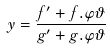Convert formula to latex. <formula><loc_0><loc_0><loc_500><loc_500>y = \frac { f ^ { \prime } + f . \varphi \vartheta } { g ^ { \prime } + g . \varphi \vartheta }</formula> 